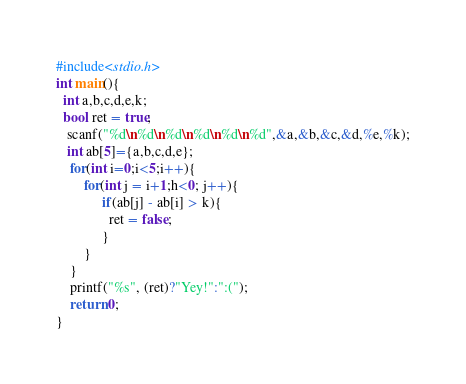<code> <loc_0><loc_0><loc_500><loc_500><_C_>#include<stdio.h>
int main(){
  int a,b,c,d,e,k;
  bool ret = true;
   scanf("%d\n%d\n%d\n%d\n%d\n%d",&a,&b,&c,&d,%e,%k);
   int ab[5]={a,b,c,d,e};
    for(int i=0;i<5;i++){
        for(int j = i+1;h<0; j++){
             if(ab[j] - ab[i] > k){
               ret = false;
             }
        }
    }
    printf("%s", (ret)?"Yey!":":(");
    return 0;
}</code> 